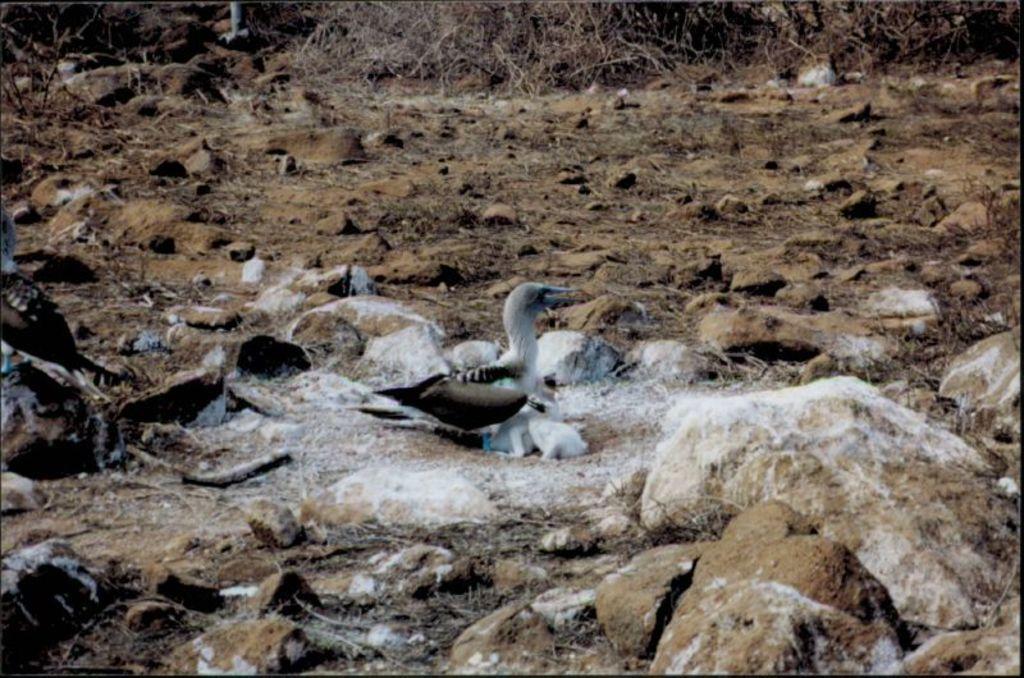Describe this image in one or two sentences. In this image we can see some birds on the ground. We can also see some stones and some dried branches of the tree on the ground. 